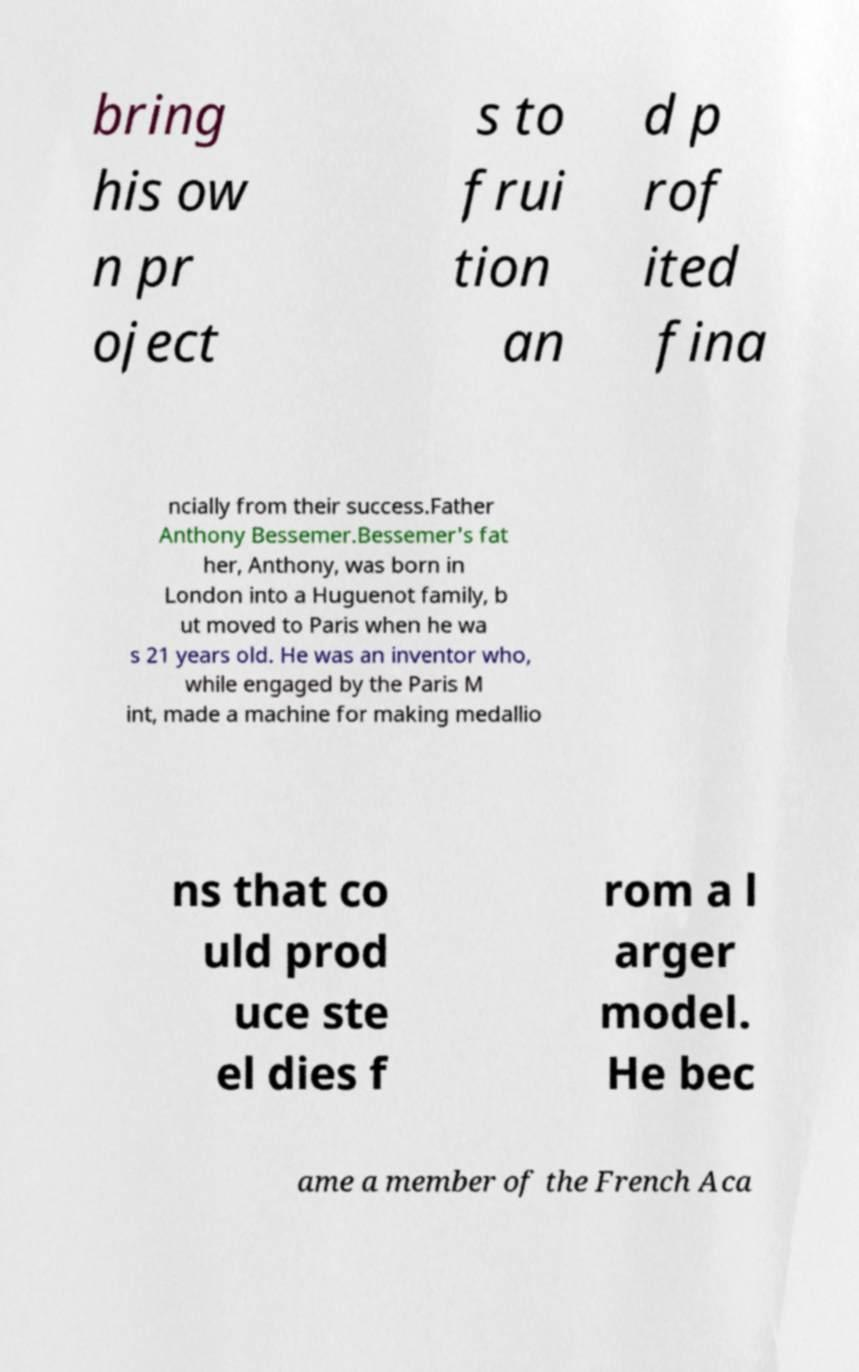What messages or text are displayed in this image? I need them in a readable, typed format. bring his ow n pr oject s to frui tion an d p rof ited fina ncially from their success.Father Anthony Bessemer.Bessemer's fat her, Anthony, was born in London into a Huguenot family, b ut moved to Paris when he wa s 21 years old. He was an inventor who, while engaged by the Paris M int, made a machine for making medallio ns that co uld prod uce ste el dies f rom a l arger model. He bec ame a member of the French Aca 